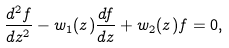<formula> <loc_0><loc_0><loc_500><loc_500>\frac { d ^ { 2 } f } { d z ^ { 2 } } - w _ { 1 } ( z ) \frac { d f } { d z } + w _ { 2 } ( z ) f = 0 ,</formula> 